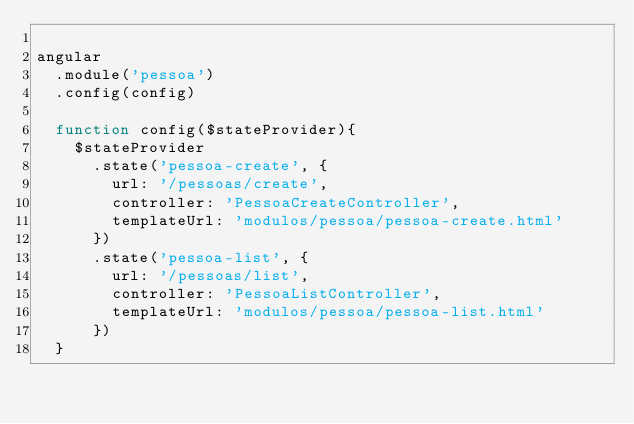<code> <loc_0><loc_0><loc_500><loc_500><_JavaScript_>
angular
  .module('pessoa')
  .config(config)

  function config($stateProvider){
    $stateProvider
      .state('pessoa-create', {
        url: '/pessoas/create',
        controller: 'PessoaCreateController',
        templateUrl: 'modulos/pessoa/pessoa-create.html'
      })
      .state('pessoa-list', {
        url: '/pessoas/list',
        controller: 'PessoaListController',
        templateUrl: 'modulos/pessoa/pessoa-list.html'
      })
  }</code> 